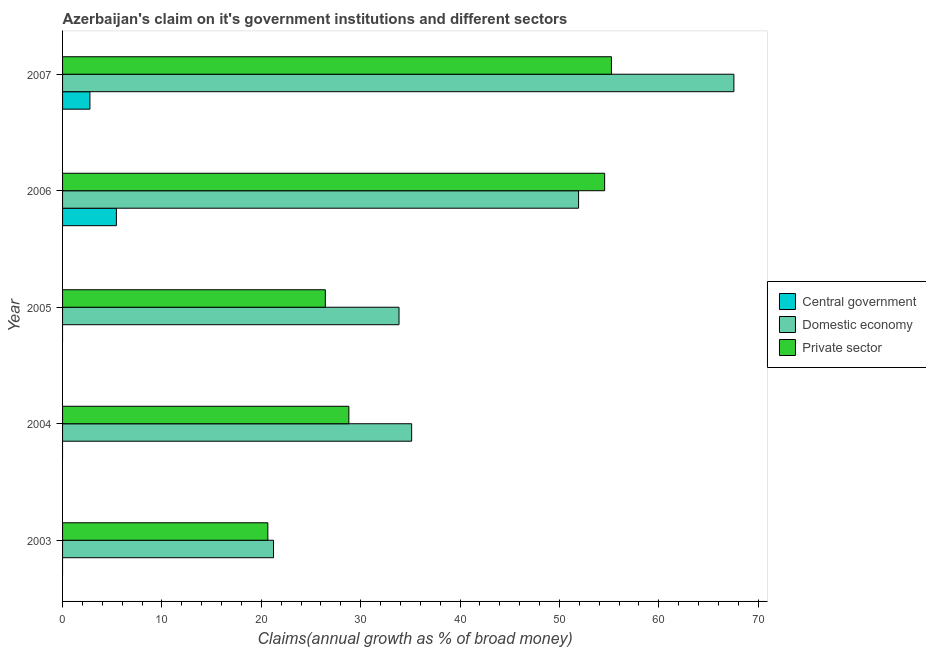How many groups of bars are there?
Keep it short and to the point. 5. Are the number of bars on each tick of the Y-axis equal?
Give a very brief answer. No. What is the percentage of claim on the private sector in 2007?
Offer a terse response. 55.23. Across all years, what is the maximum percentage of claim on the central government?
Ensure brevity in your answer.  5.42. In which year was the percentage of claim on the domestic economy maximum?
Offer a terse response. 2007. What is the total percentage of claim on the central government in the graph?
Offer a very short reply. 8.17. What is the difference between the percentage of claim on the domestic economy in 2003 and that in 2004?
Your response must be concise. -13.9. What is the difference between the percentage of claim on the private sector in 2004 and the percentage of claim on the domestic economy in 2005?
Offer a very short reply. -5.05. What is the average percentage of claim on the private sector per year?
Provide a succinct answer. 37.13. In the year 2003, what is the difference between the percentage of claim on the private sector and percentage of claim on the domestic economy?
Make the answer very short. -0.57. In how many years, is the percentage of claim on the private sector greater than 32 %?
Provide a short and direct response. 2. What is the ratio of the percentage of claim on the private sector in 2005 to that in 2007?
Your answer should be compact. 0.48. Is the percentage of claim on the domestic economy in 2003 less than that in 2005?
Keep it short and to the point. Yes. Is the difference between the percentage of claim on the domestic economy in 2004 and 2005 greater than the difference between the percentage of claim on the private sector in 2004 and 2005?
Give a very brief answer. No. What is the difference between the highest and the second highest percentage of claim on the private sector?
Your response must be concise. 0.69. What is the difference between the highest and the lowest percentage of claim on the private sector?
Your response must be concise. 34.57. In how many years, is the percentage of claim on the private sector greater than the average percentage of claim on the private sector taken over all years?
Make the answer very short. 2. Is the sum of the percentage of claim on the domestic economy in 2004 and 2006 greater than the maximum percentage of claim on the central government across all years?
Ensure brevity in your answer.  Yes. Are all the bars in the graph horizontal?
Provide a succinct answer. Yes. How many years are there in the graph?
Provide a short and direct response. 5. What is the difference between two consecutive major ticks on the X-axis?
Keep it short and to the point. 10. Does the graph contain any zero values?
Provide a short and direct response. Yes. How many legend labels are there?
Your response must be concise. 3. What is the title of the graph?
Make the answer very short. Azerbaijan's claim on it's government institutions and different sectors. What is the label or title of the X-axis?
Make the answer very short. Claims(annual growth as % of broad money). What is the label or title of the Y-axis?
Your response must be concise. Year. What is the Claims(annual growth as % of broad money) of Central government in 2003?
Provide a succinct answer. 0. What is the Claims(annual growth as % of broad money) of Domestic economy in 2003?
Your answer should be very brief. 21.23. What is the Claims(annual growth as % of broad money) of Private sector in 2003?
Ensure brevity in your answer.  20.65. What is the Claims(annual growth as % of broad money) in Domestic economy in 2004?
Keep it short and to the point. 35.12. What is the Claims(annual growth as % of broad money) in Private sector in 2004?
Keep it short and to the point. 28.81. What is the Claims(annual growth as % of broad money) in Domestic economy in 2005?
Ensure brevity in your answer.  33.85. What is the Claims(annual growth as % of broad money) in Private sector in 2005?
Offer a terse response. 26.44. What is the Claims(annual growth as % of broad money) in Central government in 2006?
Make the answer very short. 5.42. What is the Claims(annual growth as % of broad money) in Domestic economy in 2006?
Make the answer very short. 51.92. What is the Claims(annual growth as % of broad money) of Private sector in 2006?
Your response must be concise. 54.54. What is the Claims(annual growth as % of broad money) in Central government in 2007?
Your answer should be very brief. 2.75. What is the Claims(annual growth as % of broad money) in Domestic economy in 2007?
Provide a short and direct response. 67.55. What is the Claims(annual growth as % of broad money) of Private sector in 2007?
Offer a very short reply. 55.23. Across all years, what is the maximum Claims(annual growth as % of broad money) of Central government?
Your answer should be very brief. 5.42. Across all years, what is the maximum Claims(annual growth as % of broad money) of Domestic economy?
Ensure brevity in your answer.  67.55. Across all years, what is the maximum Claims(annual growth as % of broad money) in Private sector?
Give a very brief answer. 55.23. Across all years, what is the minimum Claims(annual growth as % of broad money) of Central government?
Provide a succinct answer. 0. Across all years, what is the minimum Claims(annual growth as % of broad money) of Domestic economy?
Provide a short and direct response. 21.23. Across all years, what is the minimum Claims(annual growth as % of broad money) in Private sector?
Your answer should be very brief. 20.65. What is the total Claims(annual growth as % of broad money) of Central government in the graph?
Give a very brief answer. 8.17. What is the total Claims(annual growth as % of broad money) in Domestic economy in the graph?
Your answer should be very brief. 209.68. What is the total Claims(annual growth as % of broad money) of Private sector in the graph?
Make the answer very short. 185.67. What is the difference between the Claims(annual growth as % of broad money) of Domestic economy in 2003 and that in 2004?
Keep it short and to the point. -13.9. What is the difference between the Claims(annual growth as % of broad money) in Private sector in 2003 and that in 2004?
Your response must be concise. -8.15. What is the difference between the Claims(annual growth as % of broad money) of Domestic economy in 2003 and that in 2005?
Give a very brief answer. -12.63. What is the difference between the Claims(annual growth as % of broad money) in Private sector in 2003 and that in 2005?
Your response must be concise. -5.79. What is the difference between the Claims(annual growth as % of broad money) of Domestic economy in 2003 and that in 2006?
Keep it short and to the point. -30.7. What is the difference between the Claims(annual growth as % of broad money) of Private sector in 2003 and that in 2006?
Offer a terse response. -33.89. What is the difference between the Claims(annual growth as % of broad money) of Domestic economy in 2003 and that in 2007?
Ensure brevity in your answer.  -46.32. What is the difference between the Claims(annual growth as % of broad money) of Private sector in 2003 and that in 2007?
Your response must be concise. -34.57. What is the difference between the Claims(annual growth as % of broad money) of Domestic economy in 2004 and that in 2005?
Your answer should be compact. 1.27. What is the difference between the Claims(annual growth as % of broad money) of Private sector in 2004 and that in 2005?
Make the answer very short. 2.37. What is the difference between the Claims(annual growth as % of broad money) of Domestic economy in 2004 and that in 2006?
Make the answer very short. -16.8. What is the difference between the Claims(annual growth as % of broad money) of Private sector in 2004 and that in 2006?
Make the answer very short. -25.74. What is the difference between the Claims(annual growth as % of broad money) of Domestic economy in 2004 and that in 2007?
Make the answer very short. -32.43. What is the difference between the Claims(annual growth as % of broad money) in Private sector in 2004 and that in 2007?
Make the answer very short. -26.42. What is the difference between the Claims(annual growth as % of broad money) of Domestic economy in 2005 and that in 2006?
Provide a short and direct response. -18.07. What is the difference between the Claims(annual growth as % of broad money) in Private sector in 2005 and that in 2006?
Give a very brief answer. -28.1. What is the difference between the Claims(annual growth as % of broad money) of Domestic economy in 2005 and that in 2007?
Your answer should be compact. -33.7. What is the difference between the Claims(annual growth as % of broad money) of Private sector in 2005 and that in 2007?
Offer a terse response. -28.79. What is the difference between the Claims(annual growth as % of broad money) in Central government in 2006 and that in 2007?
Your response must be concise. 2.66. What is the difference between the Claims(annual growth as % of broad money) of Domestic economy in 2006 and that in 2007?
Keep it short and to the point. -15.63. What is the difference between the Claims(annual growth as % of broad money) in Private sector in 2006 and that in 2007?
Your answer should be very brief. -0.69. What is the difference between the Claims(annual growth as % of broad money) of Domestic economy in 2003 and the Claims(annual growth as % of broad money) of Private sector in 2004?
Provide a succinct answer. -7.58. What is the difference between the Claims(annual growth as % of broad money) of Domestic economy in 2003 and the Claims(annual growth as % of broad money) of Private sector in 2005?
Your response must be concise. -5.21. What is the difference between the Claims(annual growth as % of broad money) of Domestic economy in 2003 and the Claims(annual growth as % of broad money) of Private sector in 2006?
Provide a short and direct response. -33.32. What is the difference between the Claims(annual growth as % of broad money) in Domestic economy in 2003 and the Claims(annual growth as % of broad money) in Private sector in 2007?
Give a very brief answer. -34. What is the difference between the Claims(annual growth as % of broad money) of Domestic economy in 2004 and the Claims(annual growth as % of broad money) of Private sector in 2005?
Make the answer very short. 8.68. What is the difference between the Claims(annual growth as % of broad money) of Domestic economy in 2004 and the Claims(annual growth as % of broad money) of Private sector in 2006?
Give a very brief answer. -19.42. What is the difference between the Claims(annual growth as % of broad money) in Domestic economy in 2004 and the Claims(annual growth as % of broad money) in Private sector in 2007?
Make the answer very short. -20.11. What is the difference between the Claims(annual growth as % of broad money) of Domestic economy in 2005 and the Claims(annual growth as % of broad money) of Private sector in 2006?
Your response must be concise. -20.69. What is the difference between the Claims(annual growth as % of broad money) in Domestic economy in 2005 and the Claims(annual growth as % of broad money) in Private sector in 2007?
Ensure brevity in your answer.  -21.37. What is the difference between the Claims(annual growth as % of broad money) of Central government in 2006 and the Claims(annual growth as % of broad money) of Domestic economy in 2007?
Ensure brevity in your answer.  -62.13. What is the difference between the Claims(annual growth as % of broad money) in Central government in 2006 and the Claims(annual growth as % of broad money) in Private sector in 2007?
Your response must be concise. -49.81. What is the difference between the Claims(annual growth as % of broad money) of Domestic economy in 2006 and the Claims(annual growth as % of broad money) of Private sector in 2007?
Provide a short and direct response. -3.31. What is the average Claims(annual growth as % of broad money) of Central government per year?
Make the answer very short. 1.63. What is the average Claims(annual growth as % of broad money) of Domestic economy per year?
Ensure brevity in your answer.  41.94. What is the average Claims(annual growth as % of broad money) in Private sector per year?
Your response must be concise. 37.13. In the year 2003, what is the difference between the Claims(annual growth as % of broad money) in Domestic economy and Claims(annual growth as % of broad money) in Private sector?
Keep it short and to the point. 0.57. In the year 2004, what is the difference between the Claims(annual growth as % of broad money) in Domestic economy and Claims(annual growth as % of broad money) in Private sector?
Your answer should be very brief. 6.32. In the year 2005, what is the difference between the Claims(annual growth as % of broad money) in Domestic economy and Claims(annual growth as % of broad money) in Private sector?
Ensure brevity in your answer.  7.41. In the year 2006, what is the difference between the Claims(annual growth as % of broad money) in Central government and Claims(annual growth as % of broad money) in Domestic economy?
Ensure brevity in your answer.  -46.51. In the year 2006, what is the difference between the Claims(annual growth as % of broad money) of Central government and Claims(annual growth as % of broad money) of Private sector?
Keep it short and to the point. -49.13. In the year 2006, what is the difference between the Claims(annual growth as % of broad money) of Domestic economy and Claims(annual growth as % of broad money) of Private sector?
Give a very brief answer. -2.62. In the year 2007, what is the difference between the Claims(annual growth as % of broad money) in Central government and Claims(annual growth as % of broad money) in Domestic economy?
Offer a terse response. -64.8. In the year 2007, what is the difference between the Claims(annual growth as % of broad money) in Central government and Claims(annual growth as % of broad money) in Private sector?
Provide a succinct answer. -52.48. In the year 2007, what is the difference between the Claims(annual growth as % of broad money) in Domestic economy and Claims(annual growth as % of broad money) in Private sector?
Provide a short and direct response. 12.32. What is the ratio of the Claims(annual growth as % of broad money) in Domestic economy in 2003 to that in 2004?
Give a very brief answer. 0.6. What is the ratio of the Claims(annual growth as % of broad money) in Private sector in 2003 to that in 2004?
Your answer should be compact. 0.72. What is the ratio of the Claims(annual growth as % of broad money) of Domestic economy in 2003 to that in 2005?
Offer a terse response. 0.63. What is the ratio of the Claims(annual growth as % of broad money) in Private sector in 2003 to that in 2005?
Your answer should be very brief. 0.78. What is the ratio of the Claims(annual growth as % of broad money) in Domestic economy in 2003 to that in 2006?
Your answer should be compact. 0.41. What is the ratio of the Claims(annual growth as % of broad money) of Private sector in 2003 to that in 2006?
Give a very brief answer. 0.38. What is the ratio of the Claims(annual growth as % of broad money) of Domestic economy in 2003 to that in 2007?
Your answer should be compact. 0.31. What is the ratio of the Claims(annual growth as % of broad money) of Private sector in 2003 to that in 2007?
Your response must be concise. 0.37. What is the ratio of the Claims(annual growth as % of broad money) in Domestic economy in 2004 to that in 2005?
Your answer should be very brief. 1.04. What is the ratio of the Claims(annual growth as % of broad money) of Private sector in 2004 to that in 2005?
Your answer should be very brief. 1.09. What is the ratio of the Claims(annual growth as % of broad money) of Domestic economy in 2004 to that in 2006?
Make the answer very short. 0.68. What is the ratio of the Claims(annual growth as % of broad money) in Private sector in 2004 to that in 2006?
Offer a very short reply. 0.53. What is the ratio of the Claims(annual growth as % of broad money) in Domestic economy in 2004 to that in 2007?
Provide a short and direct response. 0.52. What is the ratio of the Claims(annual growth as % of broad money) of Private sector in 2004 to that in 2007?
Make the answer very short. 0.52. What is the ratio of the Claims(annual growth as % of broad money) in Domestic economy in 2005 to that in 2006?
Offer a terse response. 0.65. What is the ratio of the Claims(annual growth as % of broad money) in Private sector in 2005 to that in 2006?
Give a very brief answer. 0.48. What is the ratio of the Claims(annual growth as % of broad money) of Domestic economy in 2005 to that in 2007?
Make the answer very short. 0.5. What is the ratio of the Claims(annual growth as % of broad money) in Private sector in 2005 to that in 2007?
Your answer should be compact. 0.48. What is the ratio of the Claims(annual growth as % of broad money) of Central government in 2006 to that in 2007?
Your answer should be very brief. 1.97. What is the ratio of the Claims(annual growth as % of broad money) of Domestic economy in 2006 to that in 2007?
Your answer should be very brief. 0.77. What is the ratio of the Claims(annual growth as % of broad money) of Private sector in 2006 to that in 2007?
Give a very brief answer. 0.99. What is the difference between the highest and the second highest Claims(annual growth as % of broad money) in Domestic economy?
Provide a succinct answer. 15.63. What is the difference between the highest and the second highest Claims(annual growth as % of broad money) in Private sector?
Ensure brevity in your answer.  0.69. What is the difference between the highest and the lowest Claims(annual growth as % of broad money) of Central government?
Give a very brief answer. 5.42. What is the difference between the highest and the lowest Claims(annual growth as % of broad money) in Domestic economy?
Ensure brevity in your answer.  46.32. What is the difference between the highest and the lowest Claims(annual growth as % of broad money) in Private sector?
Your answer should be very brief. 34.57. 